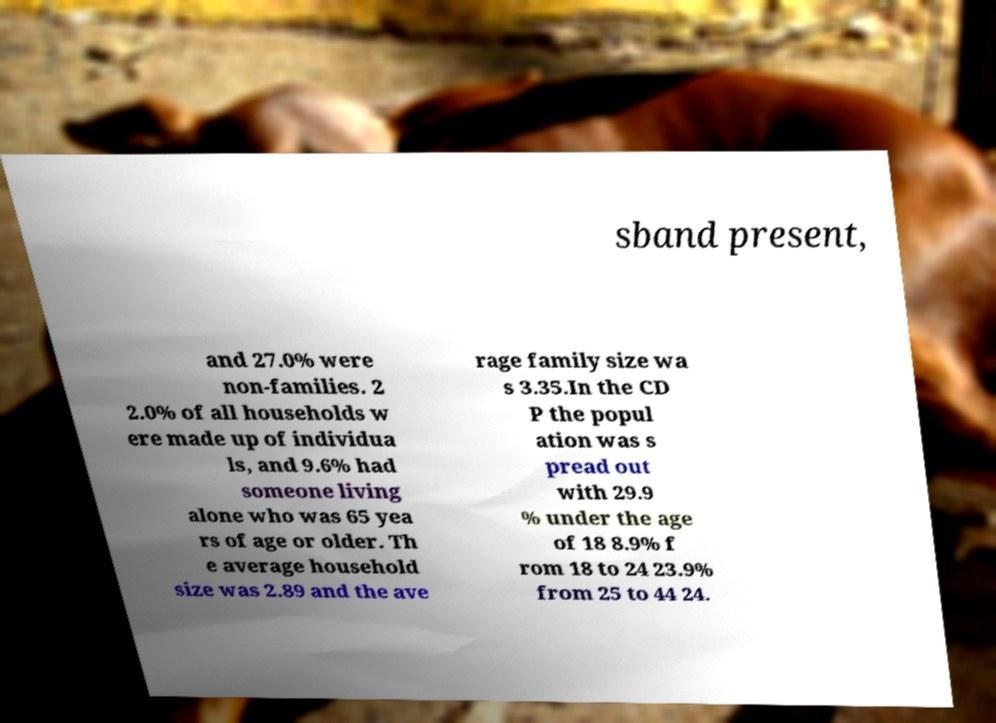Can you accurately transcribe the text from the provided image for me? sband present, and 27.0% were non-families. 2 2.0% of all households w ere made up of individua ls, and 9.6% had someone living alone who was 65 yea rs of age or older. Th e average household size was 2.89 and the ave rage family size wa s 3.35.In the CD P the popul ation was s pread out with 29.9 % under the age of 18 8.9% f rom 18 to 24 23.9% from 25 to 44 24. 